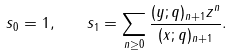Convert formula to latex. <formula><loc_0><loc_0><loc_500><loc_500>s _ { 0 } = 1 , \quad s _ { 1 } = \sum _ { n \geq 0 } \frac { ( y ; q ) _ { n + 1 } z ^ { n } } { ( x ; q ) _ { n + 1 } } .</formula> 